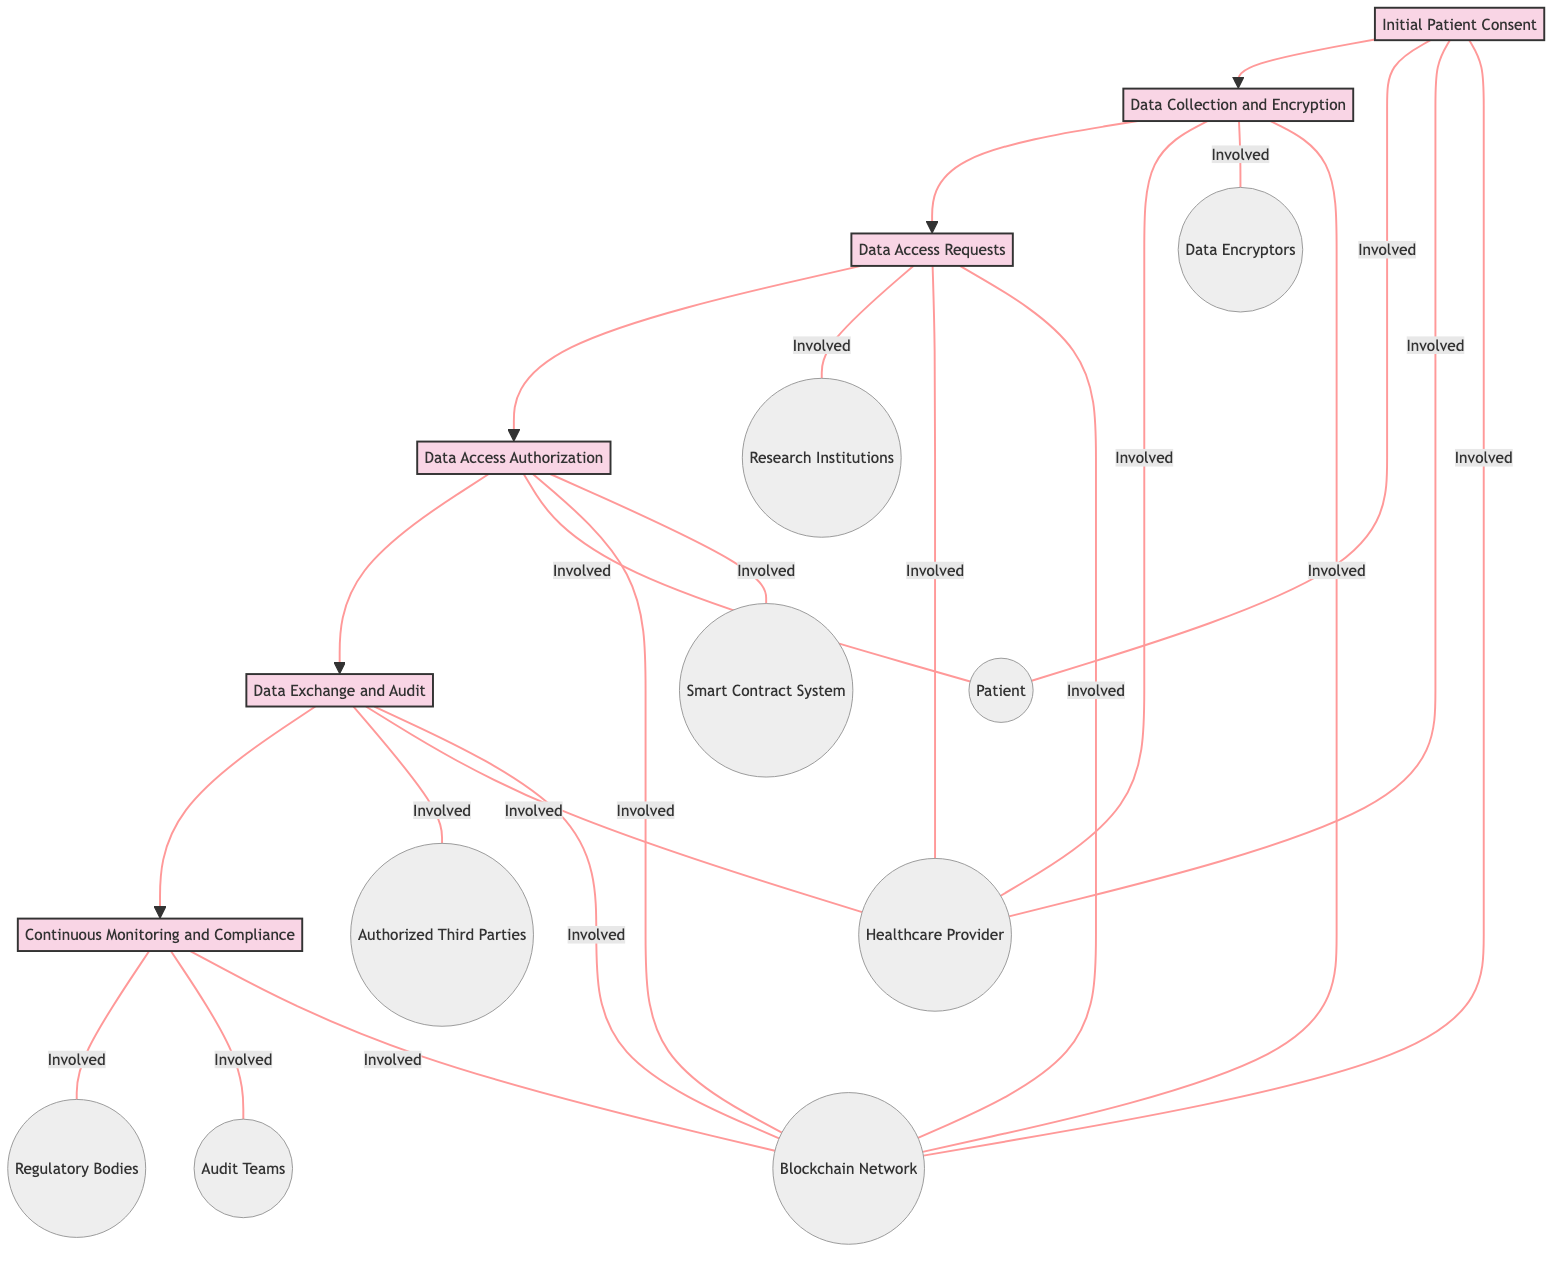What is the first step in the pathway? The first step in the pathway is indicated by the first node in the diagram, which is "Initial Patient Consent."
Answer: Initial Patient Consent How many steps are there in the pathway? By counting each distinct step in the diagram, we find that there are six steps: Initial Patient Consent, Data Collection and Encryption, Data Access Requests, Data Access Authorization, Data Exchange and Audit, and Continuous Monitoring and Compliance.
Answer: Six Which entities are involved in the "Data Access Requests" step? The diagram shows that for the "Data Access Requests" step, the involved entities include Research Institutions, Healthcare Providers, and the Blockchain Network.
Answer: Research Institutions, Healthcare Providers, Blockchain Network What triggers the access in the "Data Access Authorization" step? The "Data Access Authorization" step describes that approved requests trigger smart contracts to grant access.
Answer: Smart contracts Which step follows "Data Exchange and Audit"? According to the flow structure of the diagram, "Continuous Monitoring and Compliance" directly follows the step "Data Exchange and Audit."
Answer: Continuous Monitoring and Compliance How many entities are involved in the "Initial Patient Consent" step? The "Initial Patient Consent" step includes three entities, which are Patient, Healthcare Provider, and Blockchain Network.
Answer: Three What must be reviewed before granting data access in the pathway? The pathway indicates that the patient must review and consent to data access requests before granting access.
Answer: Patient consent Who monitors the compliance according to the diagram? The diagram specifies that regulatory bodies and audit teams are responsible for continuously monitoring compliance in the data exchange process.
Answer: Regulatory bodies, Audit teams 